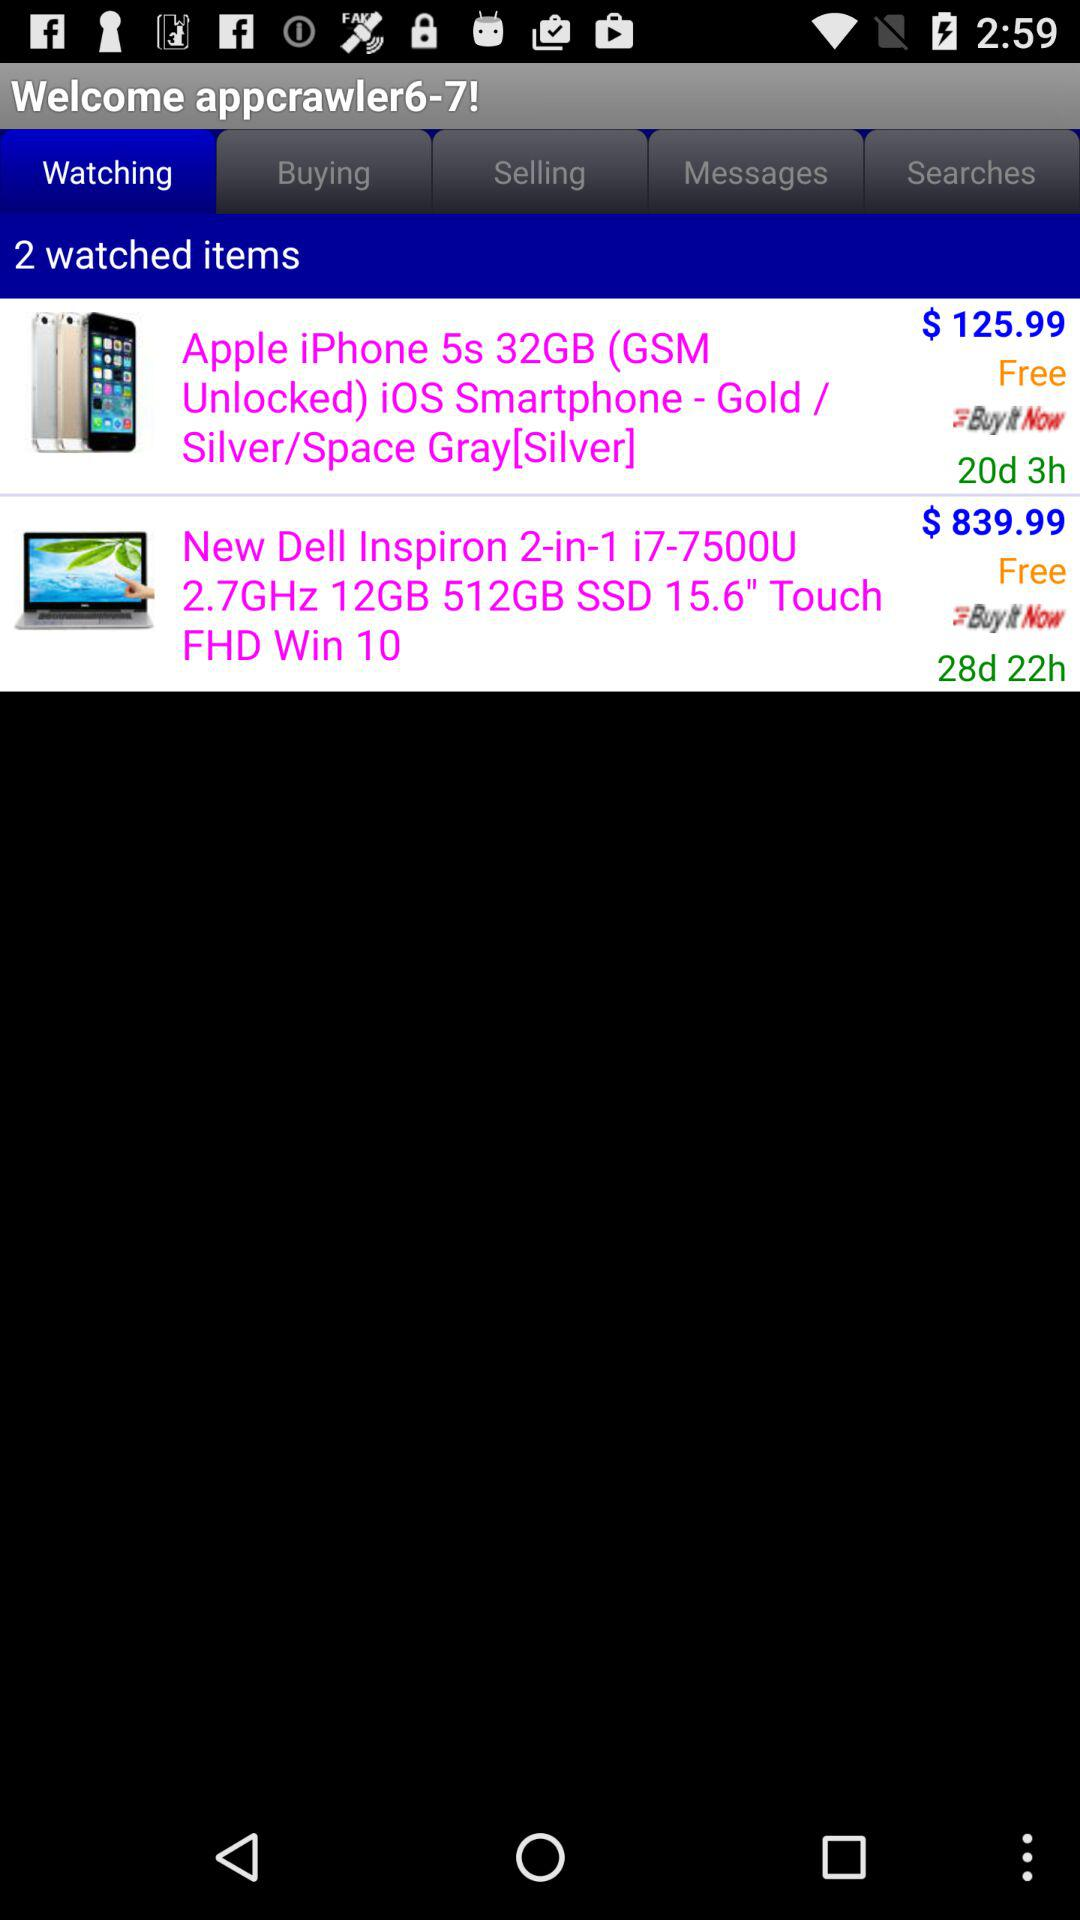Which tab is selected? The selected tab is "Watching". 